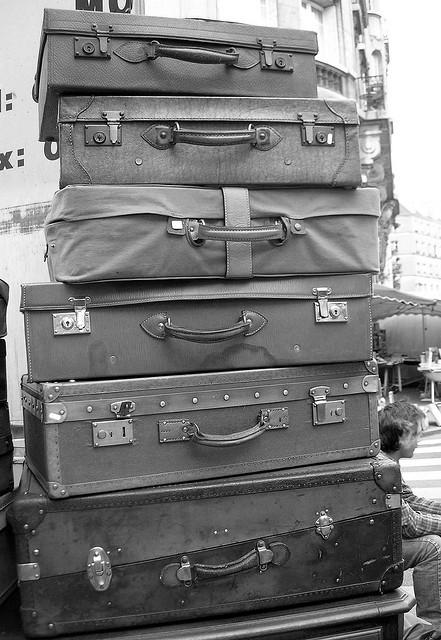How many people are visible in the picture?
Quick response, please. 1. How many suitcases are shown?
Be succinct. 6. How many suitcases are on top of each other?
Short answer required. 6. How many brown suitcases are there?
Concise answer only. 6. Is this an old picture?
Concise answer only. Yes. 